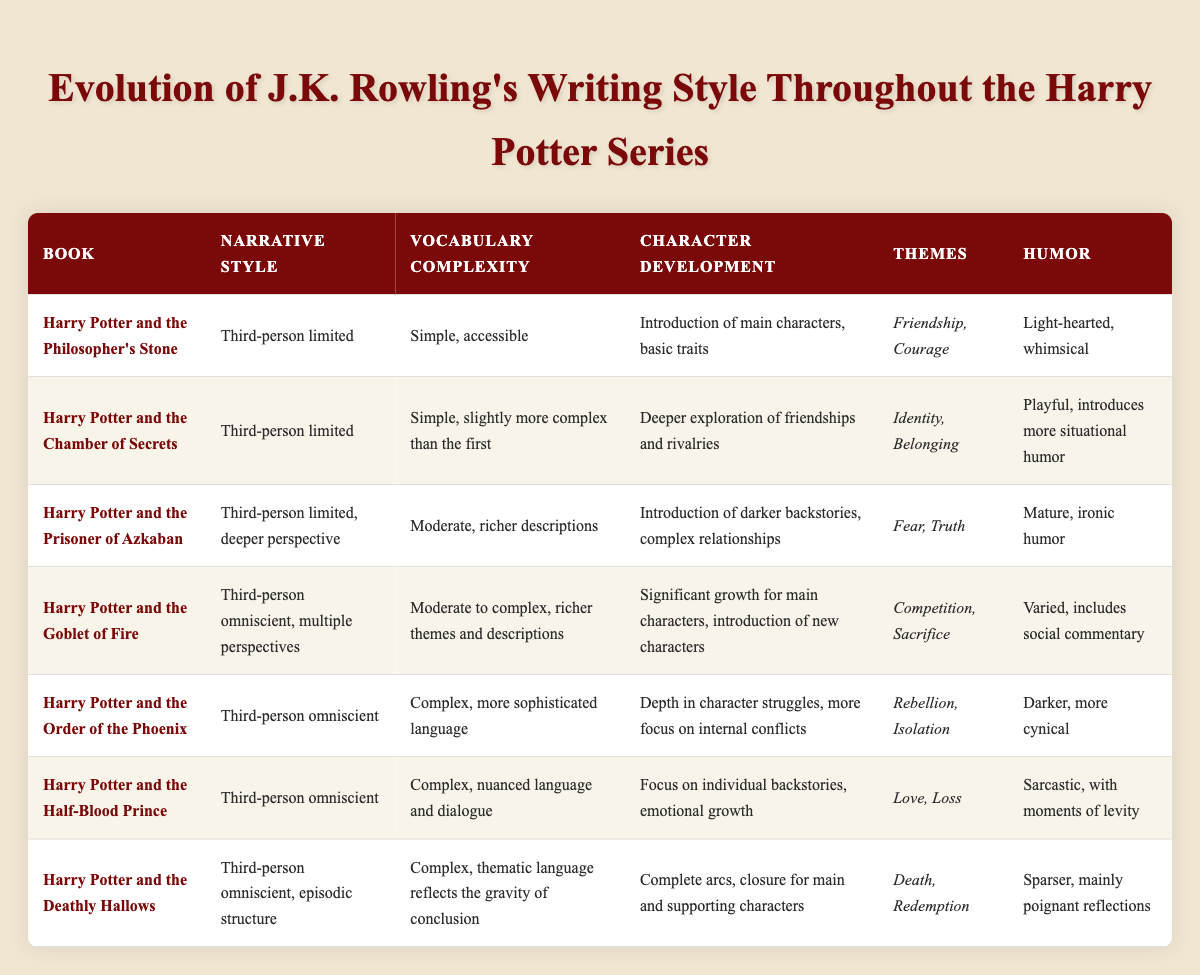What is the narrative style of "Harry Potter and the Goblet of Fire"? In the table, under the row for "Harry Potter and the Goblet of Fire," the narrative style is listed as "Third-person omniscient, multiple perspectives." This indicates the type of perspective used in that book.
Answer: Third-person omniscient, multiple perspectives Which book features the simplest vocabulary complexity? By checking the vocabulary complexity column, "Harry Potter and the Philosopher's Stone" shows the value "Simple, accessible." This is the simplest described in the table.
Answer: Harry Potter and the Philosopher's Stone Is the humor in "Harry Potter and the Order of the Phoenix" darker than in "Harry Potter and the Chamber of Secrets"? The humor description for "Harry Potter and the Order of the Phoenix" is "Darker, more cynical," while for "Harry Potter and the Chamber of Secrets," it is "Playful, introduces more situational humor." Since "Darker" is more severe than "Playful," the answer is yes.
Answer: Yes What are the main themes in "Harry Potter and the Half-Blood Prince"? In the themes column for "Harry Potter and the Half-Blood Prince," the listed themes are "Love, Loss." Those are the primary themes emphasized in that book.
Answer: Love, Loss How does the narrative style change from "Harry Potter and the Chamber of Secrets" to "Harry Potter and the Goblet of Fire"? In "Harry Potter and the Chamber of Secrets," the narrative style is "Third-person limited." In contrast, in "Harry Potter and the Goblet of Fire," it changes to "Third-person omniscient, multiple perspectives." This indicates a shift from a limited viewpoint to a broader one that includes multiple characters.
Answer: It shifts from third-person limited to third-person omniscient, multiple perspectives Which book has the most complex vocabulary? Looking at the vocabulary complexity column, "Harry Potter and the Order of the Phoenix" and "Harry Potter and the Half-Blood Prince" both feature "Complex" vocabulary. However, "Harry Potter and the Order of the Phoenix" includes "more sophisticated language," clearly indicating it is more advanced than others.
Answer: Harry Potter and the Order of the Phoenix What themes are present in "Harry Potter and the Deathly Hallows"? In the themes column for "Harry Potter and the Deathly Hallows," the themes listed are "Death, Redemption." These themes are critical to understanding the book's narrative.
Answer: Death, Redemption Which book introduces darker backstories for characters? The table indicates that "Harry Potter and the Prisoner of Azkaban" features "Introduction of darker backstories, complex relationships." This clearly points out that this book is where darker character backgrounds begin to emerge.
Answer: Harry Potter and the Prisoner of Azkaban 